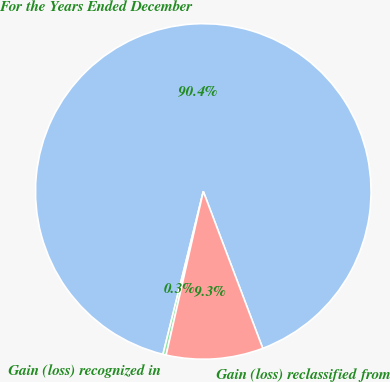<chart> <loc_0><loc_0><loc_500><loc_500><pie_chart><fcel>For the Years Ended December<fcel>Gain (loss) recognized in<fcel>Gain (loss) reclassified from<nl><fcel>90.37%<fcel>0.31%<fcel>9.32%<nl></chart> 